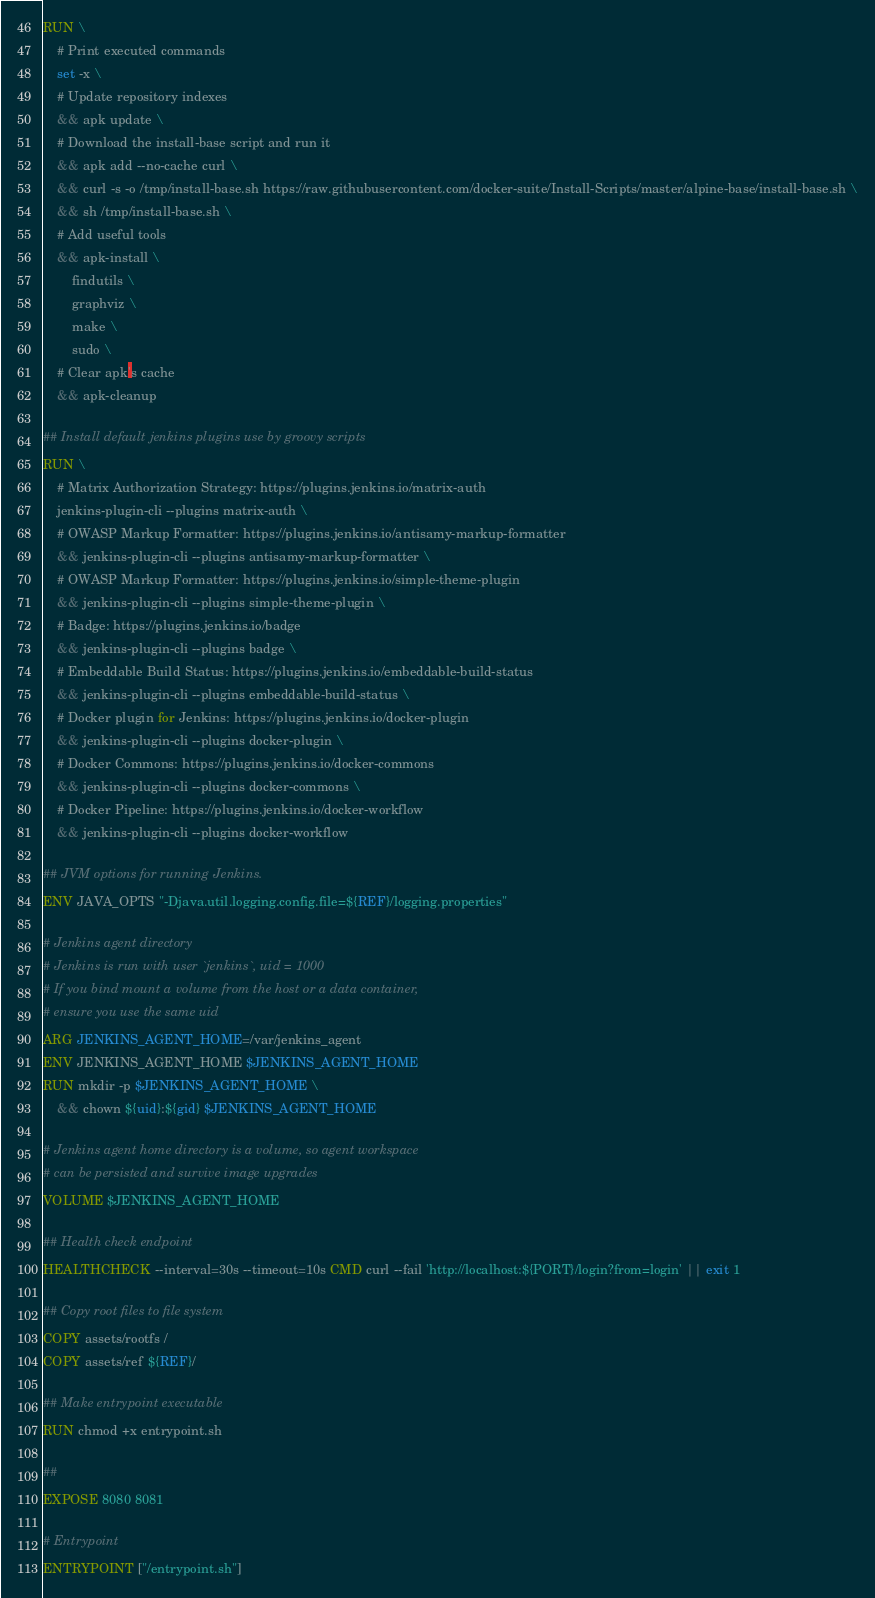Convert code to text. <code><loc_0><loc_0><loc_500><loc_500><_Dockerfile_>RUN \
	# Print executed commands
	set -x \
    # Update repository indexes
    && apk update \
    # Download the install-base script and run it
    && apk add --no-cache curl \
    && curl -s -o /tmp/install-base.sh https://raw.githubusercontent.com/docker-suite/Install-Scripts/master/alpine-base/install-base.sh \
    && sh /tmp/install-base.sh \
    # Add useful tools
    && apk-install \
        findutils \
        graphviz \
        make \
        sudo \
	# Clear apk's cache
	&& apk-cleanup

## Install default jenkins plugins use by groovy scripts
RUN \
    # Matrix Authorization Strategy: https://plugins.jenkins.io/matrix-auth
    jenkins-plugin-cli --plugins matrix-auth \
    # OWASP Markup Formatter: https://plugins.jenkins.io/antisamy-markup-formatter
    && jenkins-plugin-cli --plugins antisamy-markup-formatter \
    # OWASP Markup Formatter: https://plugins.jenkins.io/simple-theme-plugin
    && jenkins-plugin-cli --plugins simple-theme-plugin \
    # Badge: https://plugins.jenkins.io/badge
    && jenkins-plugin-cli --plugins badge \
    # Embeddable Build Status: https://plugins.jenkins.io/embeddable-build-status
    && jenkins-plugin-cli --plugins embeddable-build-status \
    # Docker plugin for Jenkins: https://plugins.jenkins.io/docker-plugin
    && jenkins-plugin-cli --plugins docker-plugin \
    # Docker Commons: https://plugins.jenkins.io/docker-commons
    && jenkins-plugin-cli --plugins docker-commons \
    # Docker Pipeline: https://plugins.jenkins.io/docker-workflow
    && jenkins-plugin-cli --plugins docker-workflow

## JVM options for running Jenkins.
ENV JAVA_OPTS "-Djava.util.logging.config.file=${REF}/logging.properties"

# Jenkins agent directory
# Jenkins is run with user `jenkins`, uid = 1000
# If you bind mount a volume from the host or a data container,
# ensure you use the same uid
ARG JENKINS_AGENT_HOME=/var/jenkins_agent
ENV JENKINS_AGENT_HOME $JENKINS_AGENT_HOME
RUN mkdir -p $JENKINS_AGENT_HOME \
    && chown ${uid}:${gid} $JENKINS_AGENT_HOME

# Jenkins agent home directory is a volume, so agent workspace
# can be persisted and survive image upgrades
VOLUME $JENKINS_AGENT_HOME

## Health check endpoint
HEALTHCHECK --interval=30s --timeout=10s CMD curl --fail 'http://localhost:${PORT}/login?from=login' || exit 1

## Copy root files to file system
COPY assets/rootfs /
COPY assets/ref ${REF}/

## Make entrypoint executable
RUN chmod +x entrypoint.sh

##
EXPOSE 8080 8081

# Entrypoint
ENTRYPOINT ["/entrypoint.sh"]
</code> 